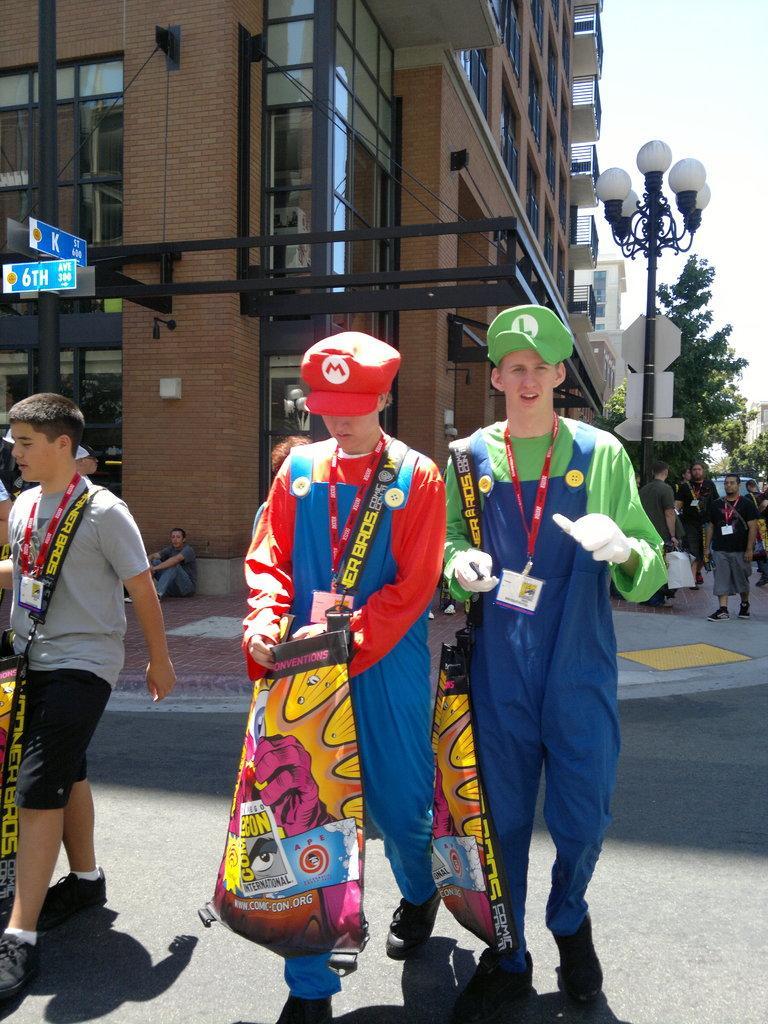Could you give a brief overview of what you see in this image? In this image there are few people walking on the road and few are walking on the pavement, one of them is sitting, in the background there are buildings, pole with boards, street lights, trees and the sky. 